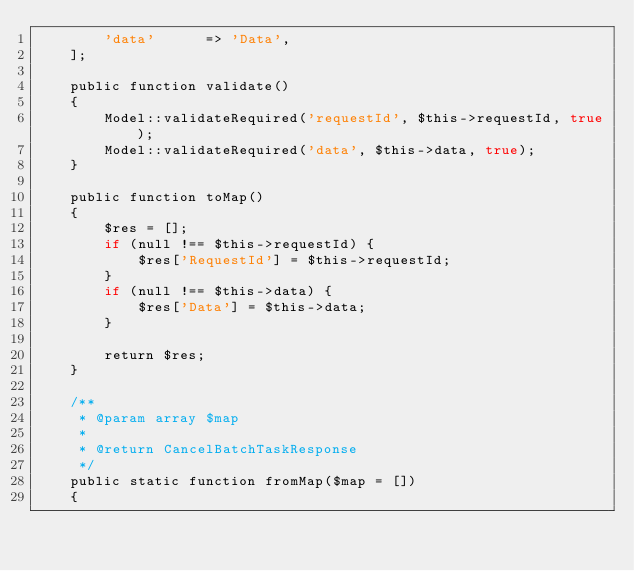Convert code to text. <code><loc_0><loc_0><loc_500><loc_500><_PHP_>        'data'      => 'Data',
    ];

    public function validate()
    {
        Model::validateRequired('requestId', $this->requestId, true);
        Model::validateRequired('data', $this->data, true);
    }

    public function toMap()
    {
        $res = [];
        if (null !== $this->requestId) {
            $res['RequestId'] = $this->requestId;
        }
        if (null !== $this->data) {
            $res['Data'] = $this->data;
        }

        return $res;
    }

    /**
     * @param array $map
     *
     * @return CancelBatchTaskResponse
     */
    public static function fromMap($map = [])
    {</code> 